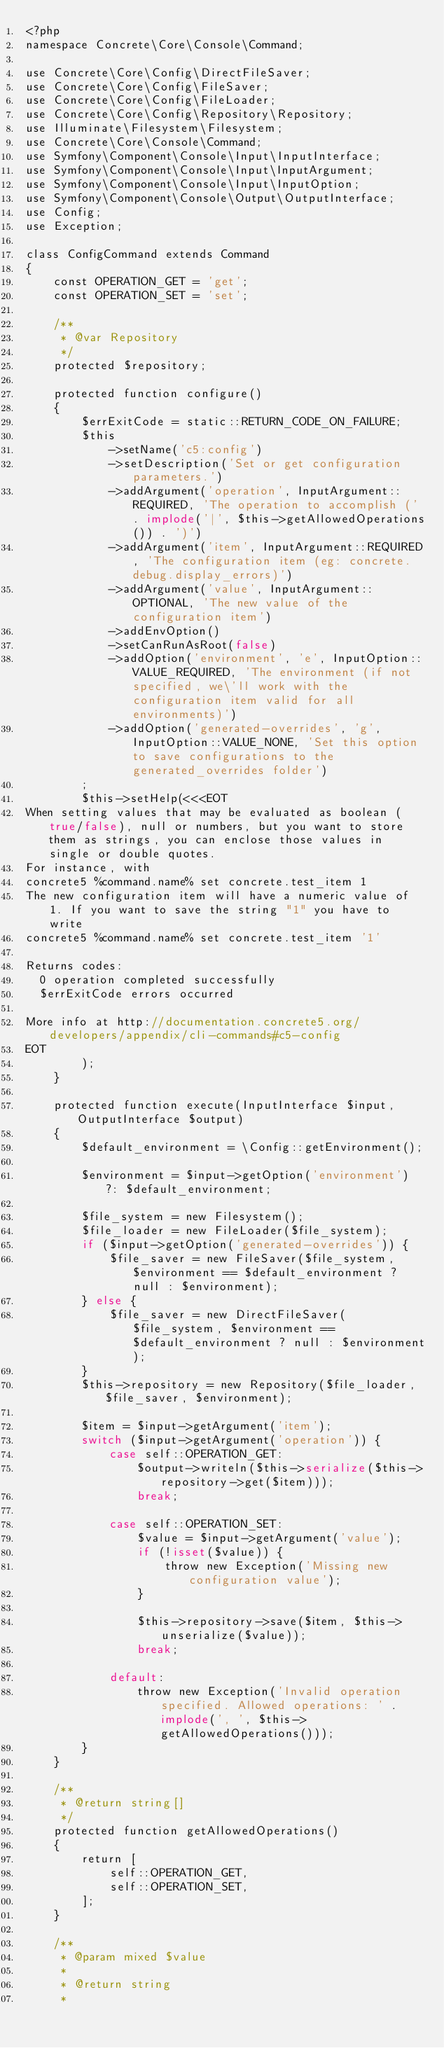Convert code to text. <code><loc_0><loc_0><loc_500><loc_500><_PHP_><?php
namespace Concrete\Core\Console\Command;

use Concrete\Core\Config\DirectFileSaver;
use Concrete\Core\Config\FileSaver;
use Concrete\Core\Config\FileLoader;
use Concrete\Core\Config\Repository\Repository;
use Illuminate\Filesystem\Filesystem;
use Concrete\Core\Console\Command;
use Symfony\Component\Console\Input\InputInterface;
use Symfony\Component\Console\Input\InputArgument;
use Symfony\Component\Console\Input\InputOption;
use Symfony\Component\Console\Output\OutputInterface;
use Config;
use Exception;

class ConfigCommand extends Command
{
    const OPERATION_GET = 'get';
    const OPERATION_SET = 'set';

    /**
     * @var Repository
     */
    protected $repository;

    protected function configure()
    {
        $errExitCode = static::RETURN_CODE_ON_FAILURE;
        $this
            ->setName('c5:config')
            ->setDescription('Set or get configuration parameters.')
            ->addArgument('operation', InputArgument::REQUIRED, 'The operation to accomplish (' . implode('|', $this->getAllowedOperations()) . ')')
            ->addArgument('item', InputArgument::REQUIRED, 'The configuration item (eg: concrete.debug.display_errors)')
            ->addArgument('value', InputArgument::OPTIONAL, 'The new value of the configuration item')
            ->addEnvOption()
            ->setCanRunAsRoot(false)
            ->addOption('environment', 'e', InputOption::VALUE_REQUIRED, 'The environment (if not specified, we\'ll work with the configuration item valid for all environments)')
            ->addOption('generated-overrides', 'g', InputOption::VALUE_NONE, 'Set this option to save configurations to the generated_overrides folder')
        ;
        $this->setHelp(<<<EOT
When setting values that may be evaluated as boolean (true/false), null or numbers, but you want to store them as strings, you can enclose those values in single or double quotes.
For instance, with
concrete5 %command.name% set concrete.test_item 1
The new configuration item will have a numeric value of 1. If you want to save the string "1" you have to write
concrete5 %command.name% set concrete.test_item '1'

Returns codes:
  0 operation completed successfully
  $errExitCode errors occurred

More info at http://documentation.concrete5.org/developers/appendix/cli-commands#c5-config
EOT
        );
    }

    protected function execute(InputInterface $input, OutputInterface $output)
    {
        $default_environment = \Config::getEnvironment();

        $environment = $input->getOption('environment') ?: $default_environment;

        $file_system = new Filesystem();
        $file_loader = new FileLoader($file_system);
        if ($input->getOption('generated-overrides')) {
            $file_saver = new FileSaver($file_system, $environment == $default_environment ? null : $environment);
        } else {
            $file_saver = new DirectFileSaver($file_system, $environment == $default_environment ? null : $environment);
        }
        $this->repository = new Repository($file_loader, $file_saver, $environment);

        $item = $input->getArgument('item');
        switch ($input->getArgument('operation')) {
            case self::OPERATION_GET:
                $output->writeln($this->serialize($this->repository->get($item)));
                break;

            case self::OPERATION_SET:
                $value = $input->getArgument('value');
                if (!isset($value)) {
                    throw new Exception('Missing new configuration value');
                }

                $this->repository->save($item, $this->unserialize($value));
                break;

            default:
                throw new Exception('Invalid operation specified. Allowed operations: ' . implode(', ', $this->getAllowedOperations()));
        }
    }

    /**
     * @return string[]
     */
    protected function getAllowedOperations()
    {
        return [
            self::OPERATION_GET,
            self::OPERATION_SET,
        ];
    }

    /**
     * @param mixed $value
     *
     * @return string
     *</code> 